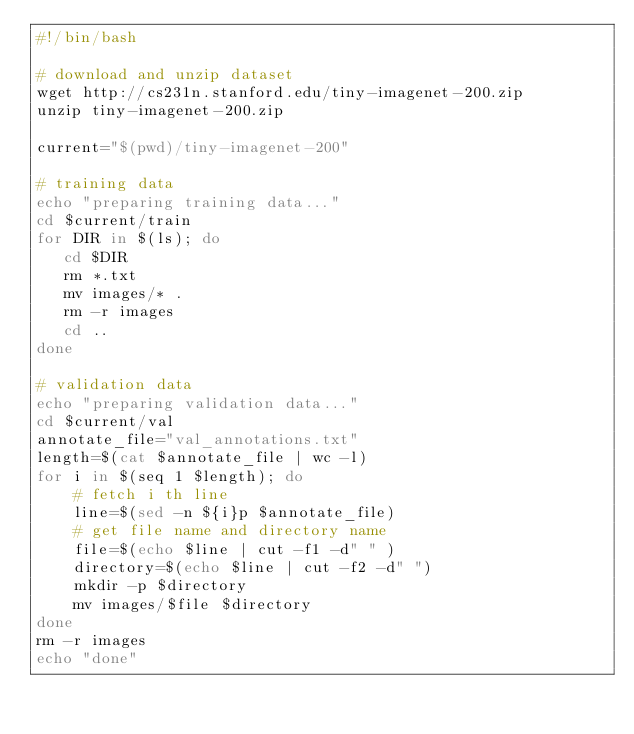<code> <loc_0><loc_0><loc_500><loc_500><_Bash_>#!/bin/bash

# download and unzip dataset
wget http://cs231n.stanford.edu/tiny-imagenet-200.zip
unzip tiny-imagenet-200.zip

current="$(pwd)/tiny-imagenet-200"

# training data
echo "preparing training data..."
cd $current/train
for DIR in $(ls); do
   cd $DIR
   rm *.txt
   mv images/* .
   rm -r images
   cd ..
done

# validation data
echo "preparing validation data..."
cd $current/val
annotate_file="val_annotations.txt"
length=$(cat $annotate_file | wc -l)
for i in $(seq 1 $length); do
    # fetch i th line
    line=$(sed -n ${i}p $annotate_file)
    # get file name and directory name
    file=$(echo $line | cut -f1 -d" " )
    directory=$(echo $line | cut -f2 -d" ")
    mkdir -p $directory
    mv images/$file $directory
done
rm -r images
echo "done"
</code> 